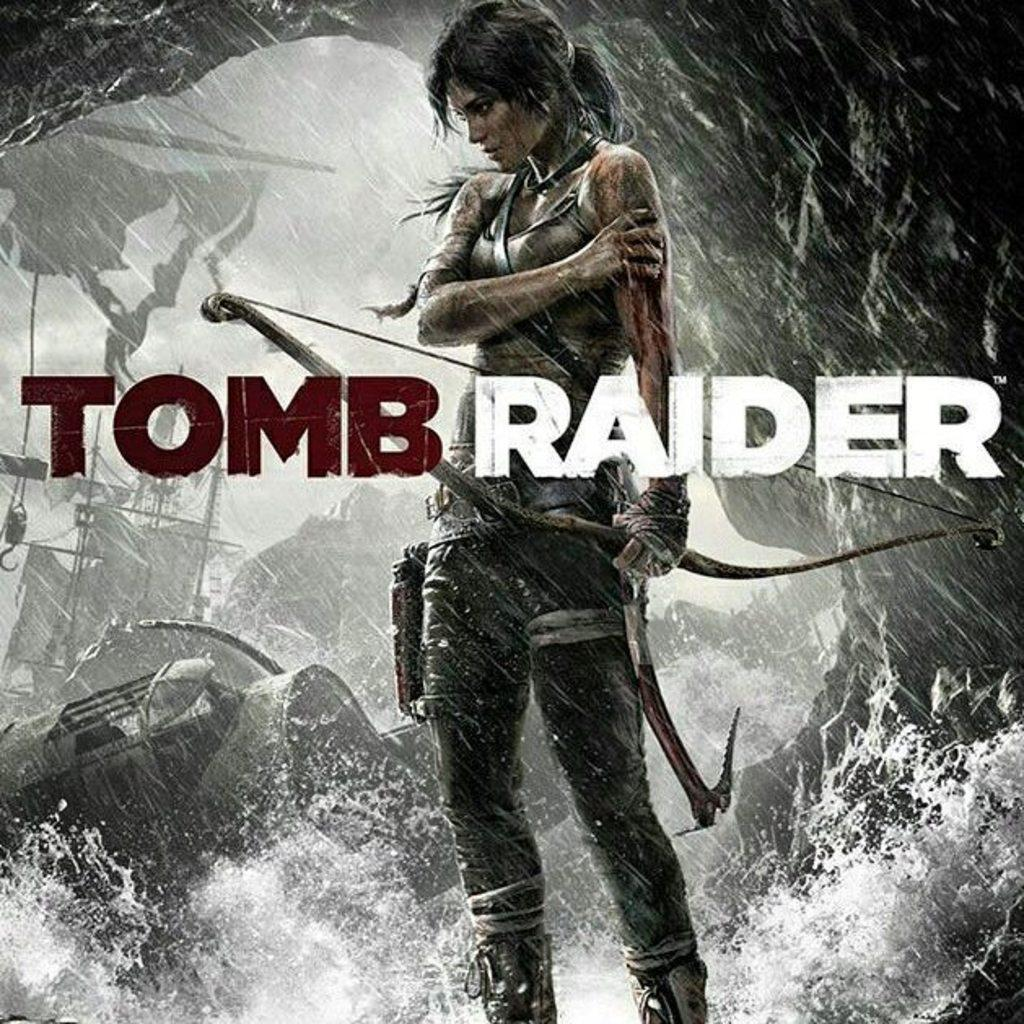Provide a one-sentence caption for the provided image. A woman is standing in the rain with a bow in a Tomb Raider advertisement. 